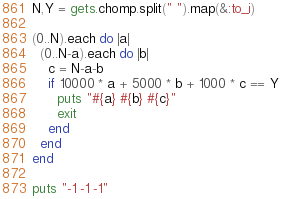<code> <loc_0><loc_0><loc_500><loc_500><_Ruby_>N,Y = gets.chomp.split(" ").map(&:to_i)

(0..N).each do |a|
  (0..N-a).each do |b|
    c = N-a-b
    if 10000 * a + 5000 * b + 1000 * c == Y
      puts "#{a} #{b} #{c}"
      exit
    end
  end
end

puts "-1 -1 -1"
</code> 